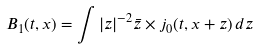Convert formula to latex. <formula><loc_0><loc_0><loc_500><loc_500>B _ { 1 } ( t , x ) = \int | z | ^ { - 2 } \bar { z } \times j _ { 0 } ( t , x + z ) \, d z</formula> 